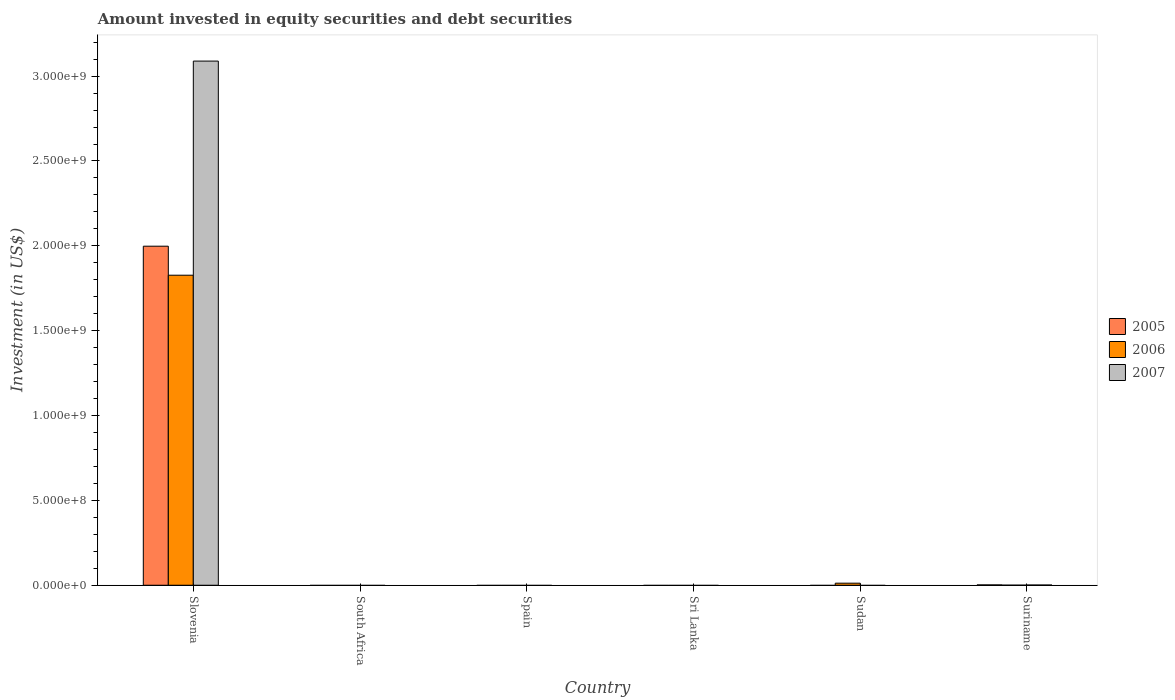Are the number of bars per tick equal to the number of legend labels?
Keep it short and to the point. No. Are the number of bars on each tick of the X-axis equal?
Ensure brevity in your answer.  No. What is the label of the 4th group of bars from the left?
Your answer should be very brief. Sri Lanka. In how many cases, is the number of bars for a given country not equal to the number of legend labels?
Your answer should be compact. 4. What is the amount invested in equity securities and debt securities in 2007 in Suriname?
Your response must be concise. 1.30e+06. Across all countries, what is the maximum amount invested in equity securities and debt securities in 2005?
Your answer should be compact. 2.00e+09. In which country was the amount invested in equity securities and debt securities in 2006 maximum?
Keep it short and to the point. Slovenia. What is the total amount invested in equity securities and debt securities in 2007 in the graph?
Your answer should be very brief. 3.09e+09. What is the difference between the amount invested in equity securities and debt securities in 2006 in Sudan and that in Suriname?
Your answer should be compact. 1.19e+07. What is the difference between the amount invested in equity securities and debt securities in 2006 in South Africa and the amount invested in equity securities and debt securities in 2007 in Spain?
Provide a short and direct response. 0. What is the average amount invested in equity securities and debt securities in 2005 per country?
Your answer should be very brief. 3.33e+08. What is the difference between the amount invested in equity securities and debt securities of/in 2007 and amount invested in equity securities and debt securities of/in 2005 in Suriname?
Offer a very short reply. -7.00e+05. What is the ratio of the amount invested in equity securities and debt securities in 2006 in Sudan to that in Suriname?
Your response must be concise. 40.54. Is the difference between the amount invested in equity securities and debt securities in 2007 in Slovenia and Suriname greater than the difference between the amount invested in equity securities and debt securities in 2005 in Slovenia and Suriname?
Your answer should be compact. Yes. What is the difference between the highest and the second highest amount invested in equity securities and debt securities in 2006?
Provide a short and direct response. -1.19e+07. What is the difference between the highest and the lowest amount invested in equity securities and debt securities in 2005?
Your response must be concise. 2.00e+09. In how many countries, is the amount invested in equity securities and debt securities in 2007 greater than the average amount invested in equity securities and debt securities in 2007 taken over all countries?
Make the answer very short. 1. Is it the case that in every country, the sum of the amount invested in equity securities and debt securities in 2007 and amount invested in equity securities and debt securities in 2006 is greater than the amount invested in equity securities and debt securities in 2005?
Your answer should be compact. No. How many bars are there?
Make the answer very short. 7. Are all the bars in the graph horizontal?
Your response must be concise. No. Are the values on the major ticks of Y-axis written in scientific E-notation?
Give a very brief answer. Yes. Does the graph contain grids?
Offer a terse response. No. Where does the legend appear in the graph?
Offer a very short reply. Center right. How many legend labels are there?
Your response must be concise. 3. What is the title of the graph?
Provide a short and direct response. Amount invested in equity securities and debt securities. What is the label or title of the X-axis?
Your response must be concise. Country. What is the label or title of the Y-axis?
Offer a terse response. Investment (in US$). What is the Investment (in US$) of 2005 in Slovenia?
Offer a very short reply. 2.00e+09. What is the Investment (in US$) in 2006 in Slovenia?
Your response must be concise. 1.83e+09. What is the Investment (in US$) of 2007 in Slovenia?
Your answer should be compact. 3.09e+09. What is the Investment (in US$) in 2005 in South Africa?
Make the answer very short. 0. What is the Investment (in US$) in 2006 in Spain?
Keep it short and to the point. 0. What is the Investment (in US$) in 2005 in Sri Lanka?
Your answer should be very brief. 0. What is the Investment (in US$) of 2005 in Sudan?
Ensure brevity in your answer.  0. What is the Investment (in US$) of 2006 in Sudan?
Provide a short and direct response. 1.22e+07. What is the Investment (in US$) of 2006 in Suriname?
Offer a very short reply. 3.00e+05. What is the Investment (in US$) in 2007 in Suriname?
Give a very brief answer. 1.30e+06. Across all countries, what is the maximum Investment (in US$) in 2005?
Provide a short and direct response. 2.00e+09. Across all countries, what is the maximum Investment (in US$) in 2006?
Your answer should be compact. 1.83e+09. Across all countries, what is the maximum Investment (in US$) of 2007?
Keep it short and to the point. 3.09e+09. Across all countries, what is the minimum Investment (in US$) of 2005?
Make the answer very short. 0. What is the total Investment (in US$) in 2005 in the graph?
Your answer should be very brief. 2.00e+09. What is the total Investment (in US$) in 2006 in the graph?
Provide a short and direct response. 1.84e+09. What is the total Investment (in US$) in 2007 in the graph?
Keep it short and to the point. 3.09e+09. What is the difference between the Investment (in US$) in 2006 in Slovenia and that in Sudan?
Provide a short and direct response. 1.81e+09. What is the difference between the Investment (in US$) of 2005 in Slovenia and that in Suriname?
Offer a terse response. 2.00e+09. What is the difference between the Investment (in US$) of 2006 in Slovenia and that in Suriname?
Ensure brevity in your answer.  1.83e+09. What is the difference between the Investment (in US$) in 2007 in Slovenia and that in Suriname?
Provide a succinct answer. 3.09e+09. What is the difference between the Investment (in US$) of 2006 in Sudan and that in Suriname?
Provide a succinct answer. 1.19e+07. What is the difference between the Investment (in US$) of 2005 in Slovenia and the Investment (in US$) of 2006 in Sudan?
Your answer should be compact. 1.99e+09. What is the difference between the Investment (in US$) of 2005 in Slovenia and the Investment (in US$) of 2006 in Suriname?
Make the answer very short. 2.00e+09. What is the difference between the Investment (in US$) in 2005 in Slovenia and the Investment (in US$) in 2007 in Suriname?
Offer a very short reply. 2.00e+09. What is the difference between the Investment (in US$) in 2006 in Slovenia and the Investment (in US$) in 2007 in Suriname?
Ensure brevity in your answer.  1.83e+09. What is the difference between the Investment (in US$) in 2006 in Sudan and the Investment (in US$) in 2007 in Suriname?
Your answer should be compact. 1.09e+07. What is the average Investment (in US$) of 2005 per country?
Offer a terse response. 3.33e+08. What is the average Investment (in US$) of 2006 per country?
Your response must be concise. 3.07e+08. What is the average Investment (in US$) of 2007 per country?
Your response must be concise. 5.15e+08. What is the difference between the Investment (in US$) in 2005 and Investment (in US$) in 2006 in Slovenia?
Provide a short and direct response. 1.71e+08. What is the difference between the Investment (in US$) of 2005 and Investment (in US$) of 2007 in Slovenia?
Give a very brief answer. -1.09e+09. What is the difference between the Investment (in US$) in 2006 and Investment (in US$) in 2007 in Slovenia?
Keep it short and to the point. -1.26e+09. What is the difference between the Investment (in US$) of 2005 and Investment (in US$) of 2006 in Suriname?
Provide a short and direct response. 1.70e+06. What is the difference between the Investment (in US$) of 2005 and Investment (in US$) of 2007 in Suriname?
Your answer should be compact. 7.00e+05. What is the difference between the Investment (in US$) in 2006 and Investment (in US$) in 2007 in Suriname?
Your answer should be compact. -1.00e+06. What is the ratio of the Investment (in US$) of 2006 in Slovenia to that in Sudan?
Offer a very short reply. 150.23. What is the ratio of the Investment (in US$) in 2005 in Slovenia to that in Suriname?
Offer a terse response. 998.95. What is the ratio of the Investment (in US$) of 2006 in Slovenia to that in Suriname?
Provide a succinct answer. 6089.77. What is the ratio of the Investment (in US$) of 2007 in Slovenia to that in Suriname?
Provide a short and direct response. 2375.91. What is the ratio of the Investment (in US$) of 2006 in Sudan to that in Suriname?
Your answer should be very brief. 40.54. What is the difference between the highest and the second highest Investment (in US$) in 2006?
Provide a succinct answer. 1.81e+09. What is the difference between the highest and the lowest Investment (in US$) of 2005?
Ensure brevity in your answer.  2.00e+09. What is the difference between the highest and the lowest Investment (in US$) in 2006?
Make the answer very short. 1.83e+09. What is the difference between the highest and the lowest Investment (in US$) in 2007?
Offer a very short reply. 3.09e+09. 